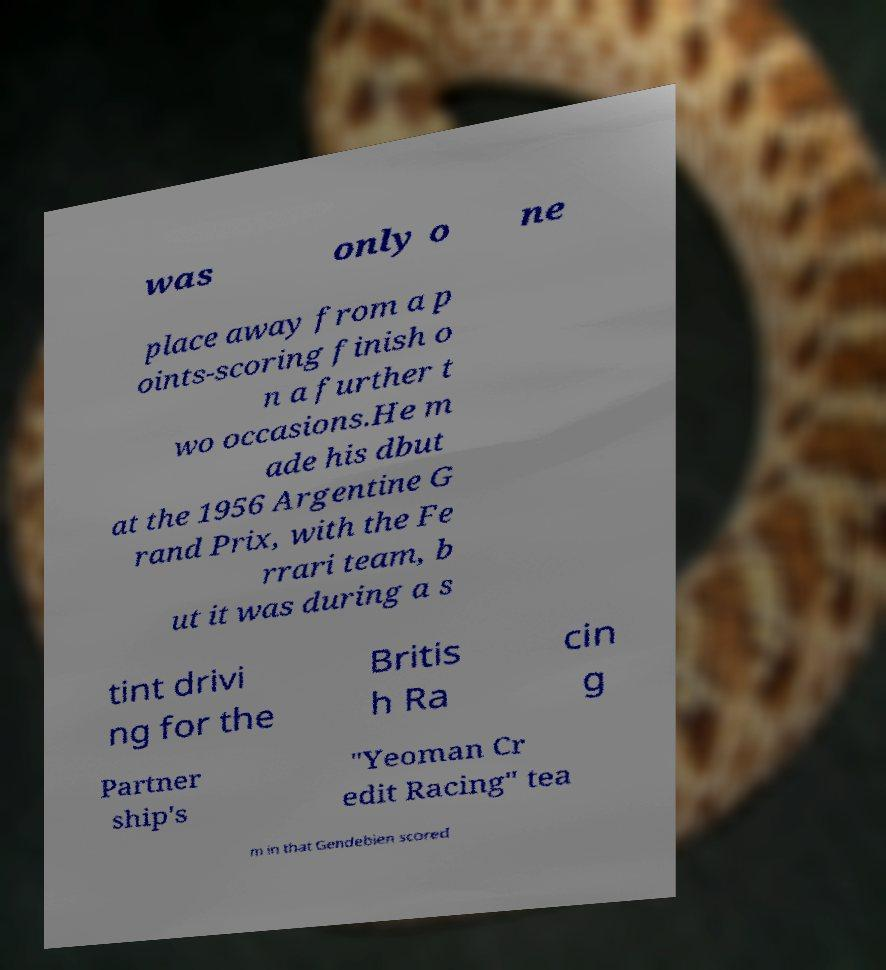There's text embedded in this image that I need extracted. Can you transcribe it verbatim? was only o ne place away from a p oints-scoring finish o n a further t wo occasions.He m ade his dbut at the 1956 Argentine G rand Prix, with the Fe rrari team, b ut it was during a s tint drivi ng for the Britis h Ra cin g Partner ship's "Yeoman Cr edit Racing" tea m in that Gendebien scored 